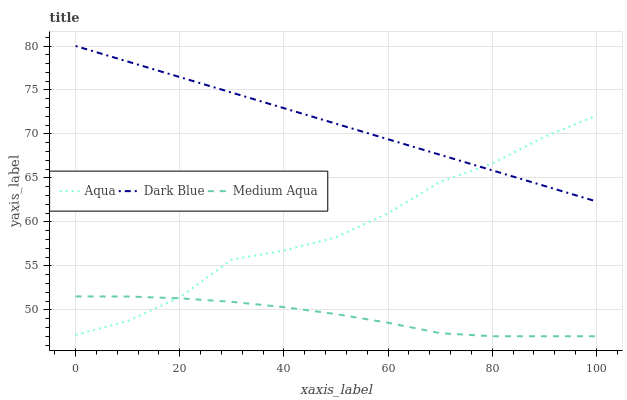Does Medium Aqua have the minimum area under the curve?
Answer yes or no. Yes. Does Dark Blue have the maximum area under the curve?
Answer yes or no. Yes. Does Aqua have the minimum area under the curve?
Answer yes or no. No. Does Aqua have the maximum area under the curve?
Answer yes or no. No. Is Dark Blue the smoothest?
Answer yes or no. Yes. Is Aqua the roughest?
Answer yes or no. Yes. Is Aqua the smoothest?
Answer yes or no. No. Is Dark Blue the roughest?
Answer yes or no. No. Does Medium Aqua have the lowest value?
Answer yes or no. Yes. Does Aqua have the lowest value?
Answer yes or no. No. Does Dark Blue have the highest value?
Answer yes or no. Yes. Does Aqua have the highest value?
Answer yes or no. No. Is Medium Aqua less than Dark Blue?
Answer yes or no. Yes. Is Dark Blue greater than Medium Aqua?
Answer yes or no. Yes. Does Dark Blue intersect Aqua?
Answer yes or no. Yes. Is Dark Blue less than Aqua?
Answer yes or no. No. Is Dark Blue greater than Aqua?
Answer yes or no. No. Does Medium Aqua intersect Dark Blue?
Answer yes or no. No. 